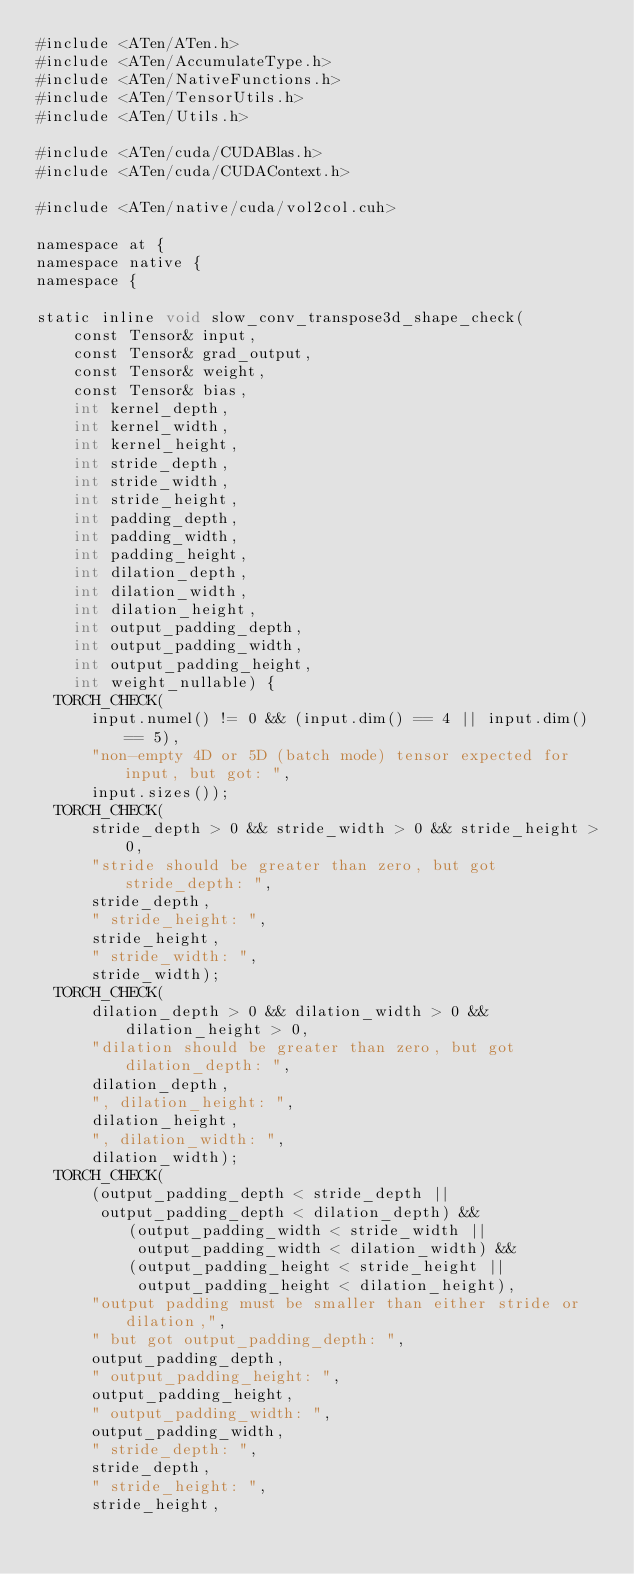<code> <loc_0><loc_0><loc_500><loc_500><_Cuda_>#include <ATen/ATen.h>
#include <ATen/AccumulateType.h>
#include <ATen/NativeFunctions.h>
#include <ATen/TensorUtils.h>
#include <ATen/Utils.h>

#include <ATen/cuda/CUDABlas.h>
#include <ATen/cuda/CUDAContext.h>

#include <ATen/native/cuda/vol2col.cuh>

namespace at {
namespace native {
namespace {

static inline void slow_conv_transpose3d_shape_check(
    const Tensor& input,
    const Tensor& grad_output,
    const Tensor& weight,
    const Tensor& bias,
    int kernel_depth,
    int kernel_width,
    int kernel_height,
    int stride_depth,
    int stride_width,
    int stride_height,
    int padding_depth,
    int padding_width,
    int padding_height,
    int dilation_depth,
    int dilation_width,
    int dilation_height,
    int output_padding_depth,
    int output_padding_width,
    int output_padding_height,
    int weight_nullable) {
  TORCH_CHECK(
      input.numel() != 0 && (input.dim() == 4 || input.dim() == 5),
      "non-empty 4D or 5D (batch mode) tensor expected for input, but got: ",
      input.sizes());
  TORCH_CHECK(
      stride_depth > 0 && stride_width > 0 && stride_height > 0,
      "stride should be greater than zero, but got stride_depth: ",
      stride_depth,
      " stride_height: ",
      stride_height,
      " stride_width: ",
      stride_width);
  TORCH_CHECK(
      dilation_depth > 0 && dilation_width > 0 && dilation_height > 0,
      "dilation should be greater than zero, but got dilation_depth: ",
      dilation_depth,
      ", dilation_height: ",
      dilation_height,
      ", dilation_width: ",
      dilation_width);
  TORCH_CHECK(
      (output_padding_depth < stride_depth ||
       output_padding_depth < dilation_depth) &&
          (output_padding_width < stride_width ||
           output_padding_width < dilation_width) &&
          (output_padding_height < stride_height ||
           output_padding_height < dilation_height),
      "output padding must be smaller than either stride or dilation,",
      " but got output_padding_depth: ",
      output_padding_depth,
      " output_padding_height: ",
      output_padding_height,
      " output_padding_width: ",
      output_padding_width,
      " stride_depth: ",
      stride_depth,
      " stride_height: ",
      stride_height,</code> 